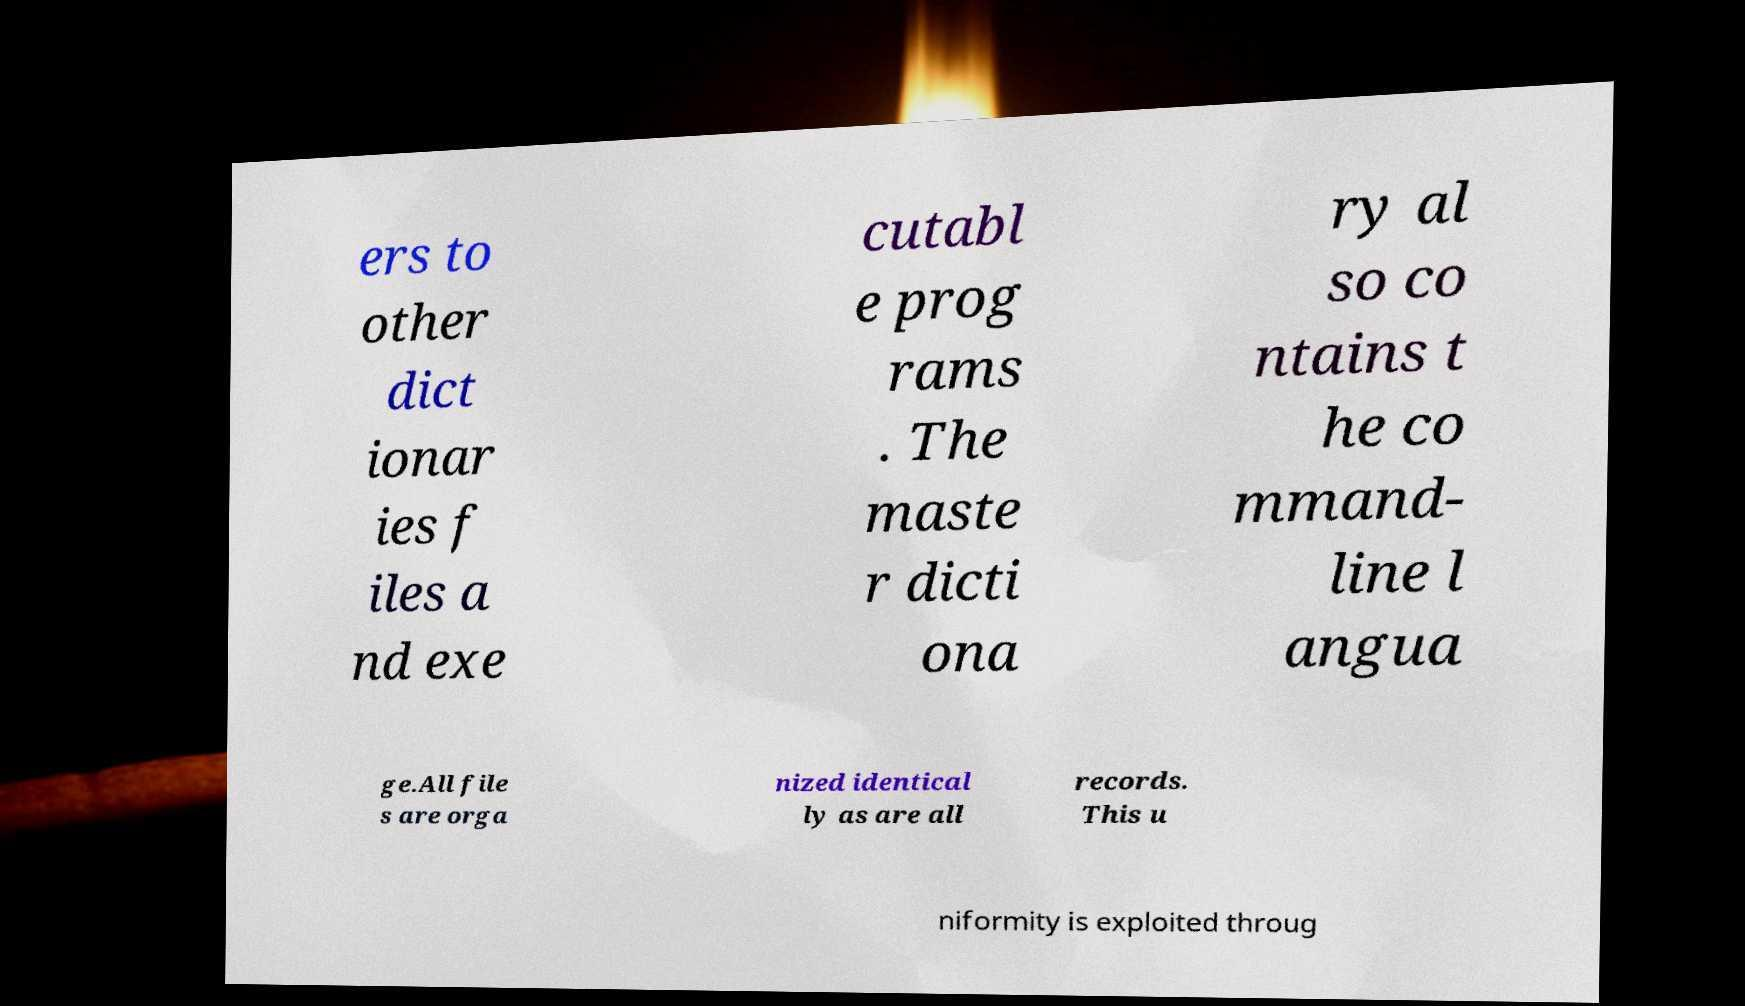Could you assist in decoding the text presented in this image and type it out clearly? ers to other dict ionar ies f iles a nd exe cutabl e prog rams . The maste r dicti ona ry al so co ntains t he co mmand- line l angua ge.All file s are orga nized identical ly as are all records. This u niformity is exploited throug 